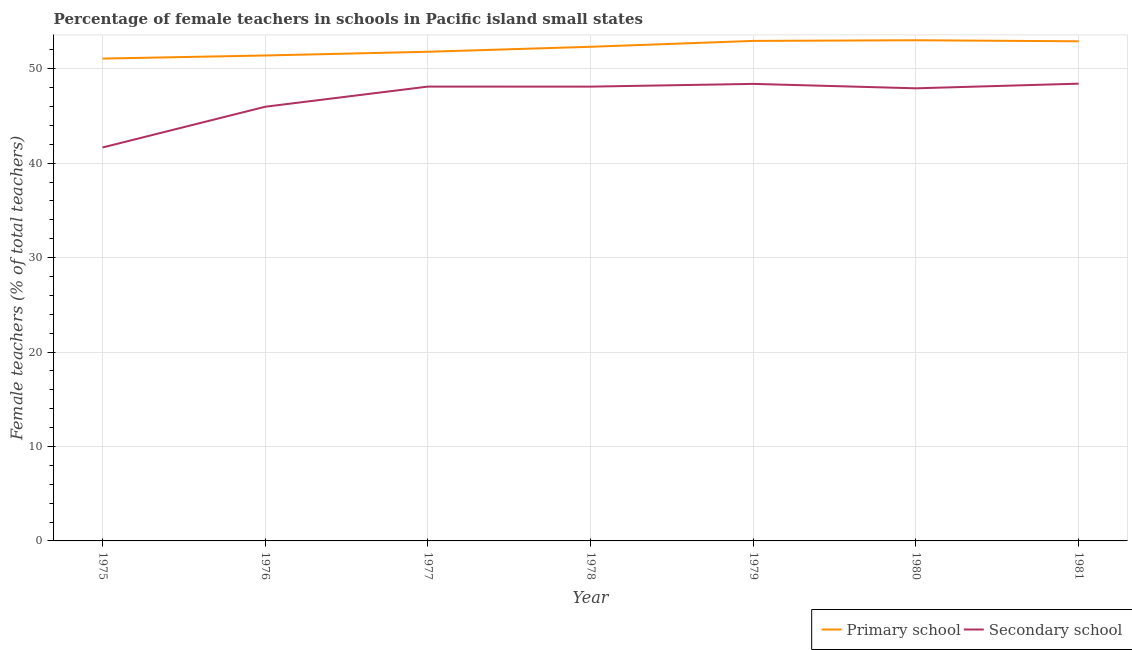How many different coloured lines are there?
Keep it short and to the point. 2. Does the line corresponding to percentage of female teachers in secondary schools intersect with the line corresponding to percentage of female teachers in primary schools?
Make the answer very short. No. What is the percentage of female teachers in secondary schools in 1979?
Your answer should be very brief. 48.4. Across all years, what is the maximum percentage of female teachers in primary schools?
Give a very brief answer. 53.02. Across all years, what is the minimum percentage of female teachers in secondary schools?
Your answer should be compact. 41.66. In which year was the percentage of female teachers in secondary schools minimum?
Your response must be concise. 1975. What is the total percentage of female teachers in secondary schools in the graph?
Offer a very short reply. 328.62. What is the difference between the percentage of female teachers in secondary schools in 1976 and that in 1980?
Provide a succinct answer. -1.95. What is the difference between the percentage of female teachers in secondary schools in 1976 and the percentage of female teachers in primary schools in 1979?
Keep it short and to the point. -6.97. What is the average percentage of female teachers in primary schools per year?
Offer a terse response. 52.21. In the year 1976, what is the difference between the percentage of female teachers in primary schools and percentage of female teachers in secondary schools?
Make the answer very short. 5.43. In how many years, is the percentage of female teachers in primary schools greater than 38 %?
Make the answer very short. 7. What is the ratio of the percentage of female teachers in secondary schools in 1975 to that in 1980?
Offer a very short reply. 0.87. Is the difference between the percentage of female teachers in primary schools in 1975 and 1977 greater than the difference between the percentage of female teachers in secondary schools in 1975 and 1977?
Offer a terse response. Yes. What is the difference between the highest and the second highest percentage of female teachers in secondary schools?
Your answer should be compact. 0.02. What is the difference between the highest and the lowest percentage of female teachers in secondary schools?
Make the answer very short. 6.76. Is the sum of the percentage of female teachers in secondary schools in 1979 and 1981 greater than the maximum percentage of female teachers in primary schools across all years?
Offer a terse response. Yes. Is the percentage of female teachers in primary schools strictly less than the percentage of female teachers in secondary schools over the years?
Give a very brief answer. No. What is the difference between two consecutive major ticks on the Y-axis?
Keep it short and to the point. 10. Where does the legend appear in the graph?
Keep it short and to the point. Bottom right. How many legend labels are there?
Your answer should be very brief. 2. How are the legend labels stacked?
Your response must be concise. Horizontal. What is the title of the graph?
Give a very brief answer. Percentage of female teachers in schools in Pacific island small states. What is the label or title of the Y-axis?
Your response must be concise. Female teachers (% of total teachers). What is the Female teachers (% of total teachers) in Primary school in 1975?
Keep it short and to the point. 51.08. What is the Female teachers (% of total teachers) of Secondary school in 1975?
Provide a succinct answer. 41.66. What is the Female teachers (% of total teachers) in Primary school in 1976?
Your answer should be compact. 51.41. What is the Female teachers (% of total teachers) of Secondary school in 1976?
Your answer should be very brief. 45.98. What is the Female teachers (% of total teachers) in Primary school in 1977?
Offer a terse response. 51.8. What is the Female teachers (% of total teachers) in Secondary school in 1977?
Keep it short and to the point. 48.11. What is the Female teachers (% of total teachers) of Primary school in 1978?
Your response must be concise. 52.33. What is the Female teachers (% of total teachers) of Secondary school in 1978?
Provide a short and direct response. 48.11. What is the Female teachers (% of total teachers) in Primary school in 1979?
Provide a short and direct response. 52.95. What is the Female teachers (% of total teachers) of Secondary school in 1979?
Offer a very short reply. 48.4. What is the Female teachers (% of total teachers) of Primary school in 1980?
Provide a succinct answer. 53.02. What is the Female teachers (% of total teachers) of Secondary school in 1980?
Give a very brief answer. 47.93. What is the Female teachers (% of total teachers) in Primary school in 1981?
Your answer should be very brief. 52.91. What is the Female teachers (% of total teachers) of Secondary school in 1981?
Provide a succinct answer. 48.42. Across all years, what is the maximum Female teachers (% of total teachers) in Primary school?
Keep it short and to the point. 53.02. Across all years, what is the maximum Female teachers (% of total teachers) of Secondary school?
Give a very brief answer. 48.42. Across all years, what is the minimum Female teachers (% of total teachers) in Primary school?
Provide a short and direct response. 51.08. Across all years, what is the minimum Female teachers (% of total teachers) in Secondary school?
Ensure brevity in your answer.  41.66. What is the total Female teachers (% of total teachers) of Primary school in the graph?
Keep it short and to the point. 365.5. What is the total Female teachers (% of total teachers) of Secondary school in the graph?
Your response must be concise. 328.62. What is the difference between the Female teachers (% of total teachers) of Primary school in 1975 and that in 1976?
Your answer should be compact. -0.33. What is the difference between the Female teachers (% of total teachers) of Secondary school in 1975 and that in 1976?
Give a very brief answer. -4.31. What is the difference between the Female teachers (% of total teachers) of Primary school in 1975 and that in 1977?
Keep it short and to the point. -0.72. What is the difference between the Female teachers (% of total teachers) of Secondary school in 1975 and that in 1977?
Provide a succinct answer. -6.45. What is the difference between the Female teachers (% of total teachers) in Primary school in 1975 and that in 1978?
Provide a short and direct response. -1.25. What is the difference between the Female teachers (% of total teachers) in Secondary school in 1975 and that in 1978?
Offer a terse response. -6.45. What is the difference between the Female teachers (% of total teachers) in Primary school in 1975 and that in 1979?
Your answer should be compact. -1.87. What is the difference between the Female teachers (% of total teachers) of Secondary school in 1975 and that in 1979?
Give a very brief answer. -6.73. What is the difference between the Female teachers (% of total teachers) in Primary school in 1975 and that in 1980?
Offer a terse response. -1.94. What is the difference between the Female teachers (% of total teachers) of Secondary school in 1975 and that in 1980?
Keep it short and to the point. -6.27. What is the difference between the Female teachers (% of total teachers) in Primary school in 1975 and that in 1981?
Offer a very short reply. -1.83. What is the difference between the Female teachers (% of total teachers) in Secondary school in 1975 and that in 1981?
Provide a succinct answer. -6.76. What is the difference between the Female teachers (% of total teachers) in Primary school in 1976 and that in 1977?
Provide a short and direct response. -0.39. What is the difference between the Female teachers (% of total teachers) of Secondary school in 1976 and that in 1977?
Provide a short and direct response. -2.13. What is the difference between the Female teachers (% of total teachers) in Primary school in 1976 and that in 1978?
Your answer should be compact. -0.92. What is the difference between the Female teachers (% of total teachers) of Secondary school in 1976 and that in 1978?
Offer a very short reply. -2.13. What is the difference between the Female teachers (% of total teachers) in Primary school in 1976 and that in 1979?
Offer a very short reply. -1.54. What is the difference between the Female teachers (% of total teachers) of Secondary school in 1976 and that in 1979?
Your answer should be compact. -2.42. What is the difference between the Female teachers (% of total teachers) of Primary school in 1976 and that in 1980?
Your response must be concise. -1.61. What is the difference between the Female teachers (% of total teachers) in Secondary school in 1976 and that in 1980?
Make the answer very short. -1.95. What is the difference between the Female teachers (% of total teachers) in Primary school in 1976 and that in 1981?
Offer a terse response. -1.5. What is the difference between the Female teachers (% of total teachers) of Secondary school in 1976 and that in 1981?
Your response must be concise. -2.44. What is the difference between the Female teachers (% of total teachers) of Primary school in 1977 and that in 1978?
Offer a terse response. -0.53. What is the difference between the Female teachers (% of total teachers) of Secondary school in 1977 and that in 1978?
Your answer should be compact. 0. What is the difference between the Female teachers (% of total teachers) in Primary school in 1977 and that in 1979?
Offer a very short reply. -1.15. What is the difference between the Female teachers (% of total teachers) of Secondary school in 1977 and that in 1979?
Offer a very short reply. -0.29. What is the difference between the Female teachers (% of total teachers) of Primary school in 1977 and that in 1980?
Your response must be concise. -1.22. What is the difference between the Female teachers (% of total teachers) in Secondary school in 1977 and that in 1980?
Ensure brevity in your answer.  0.18. What is the difference between the Female teachers (% of total teachers) of Primary school in 1977 and that in 1981?
Keep it short and to the point. -1.11. What is the difference between the Female teachers (% of total teachers) in Secondary school in 1977 and that in 1981?
Offer a very short reply. -0.31. What is the difference between the Female teachers (% of total teachers) of Primary school in 1978 and that in 1979?
Ensure brevity in your answer.  -0.62. What is the difference between the Female teachers (% of total teachers) in Secondary school in 1978 and that in 1979?
Provide a short and direct response. -0.29. What is the difference between the Female teachers (% of total teachers) in Primary school in 1978 and that in 1980?
Offer a very short reply. -0.69. What is the difference between the Female teachers (% of total teachers) in Secondary school in 1978 and that in 1980?
Your answer should be very brief. 0.18. What is the difference between the Female teachers (% of total teachers) in Primary school in 1978 and that in 1981?
Give a very brief answer. -0.58. What is the difference between the Female teachers (% of total teachers) of Secondary school in 1978 and that in 1981?
Keep it short and to the point. -0.31. What is the difference between the Female teachers (% of total teachers) in Primary school in 1979 and that in 1980?
Offer a very short reply. -0.07. What is the difference between the Female teachers (% of total teachers) of Secondary school in 1979 and that in 1980?
Your response must be concise. 0.47. What is the difference between the Female teachers (% of total teachers) in Primary school in 1979 and that in 1981?
Your response must be concise. 0.04. What is the difference between the Female teachers (% of total teachers) in Secondary school in 1979 and that in 1981?
Ensure brevity in your answer.  -0.02. What is the difference between the Female teachers (% of total teachers) of Primary school in 1980 and that in 1981?
Offer a very short reply. 0.11. What is the difference between the Female teachers (% of total teachers) of Secondary school in 1980 and that in 1981?
Provide a succinct answer. -0.49. What is the difference between the Female teachers (% of total teachers) of Primary school in 1975 and the Female teachers (% of total teachers) of Secondary school in 1976?
Provide a succinct answer. 5.1. What is the difference between the Female teachers (% of total teachers) in Primary school in 1975 and the Female teachers (% of total teachers) in Secondary school in 1977?
Your answer should be very brief. 2.97. What is the difference between the Female teachers (% of total teachers) of Primary school in 1975 and the Female teachers (% of total teachers) of Secondary school in 1978?
Make the answer very short. 2.97. What is the difference between the Female teachers (% of total teachers) in Primary school in 1975 and the Female teachers (% of total teachers) in Secondary school in 1979?
Provide a short and direct response. 2.68. What is the difference between the Female teachers (% of total teachers) in Primary school in 1975 and the Female teachers (% of total teachers) in Secondary school in 1980?
Give a very brief answer. 3.15. What is the difference between the Female teachers (% of total teachers) in Primary school in 1975 and the Female teachers (% of total teachers) in Secondary school in 1981?
Your answer should be compact. 2.66. What is the difference between the Female teachers (% of total teachers) in Primary school in 1976 and the Female teachers (% of total teachers) in Secondary school in 1977?
Provide a short and direct response. 3.29. What is the difference between the Female teachers (% of total teachers) of Primary school in 1976 and the Female teachers (% of total teachers) of Secondary school in 1978?
Offer a terse response. 3.3. What is the difference between the Female teachers (% of total teachers) in Primary school in 1976 and the Female teachers (% of total teachers) in Secondary school in 1979?
Ensure brevity in your answer.  3.01. What is the difference between the Female teachers (% of total teachers) of Primary school in 1976 and the Female teachers (% of total teachers) of Secondary school in 1980?
Your response must be concise. 3.48. What is the difference between the Female teachers (% of total teachers) in Primary school in 1976 and the Female teachers (% of total teachers) in Secondary school in 1981?
Make the answer very short. 2.98. What is the difference between the Female teachers (% of total teachers) in Primary school in 1977 and the Female teachers (% of total teachers) in Secondary school in 1978?
Ensure brevity in your answer.  3.69. What is the difference between the Female teachers (% of total teachers) of Primary school in 1977 and the Female teachers (% of total teachers) of Secondary school in 1979?
Your answer should be compact. 3.4. What is the difference between the Female teachers (% of total teachers) in Primary school in 1977 and the Female teachers (% of total teachers) in Secondary school in 1980?
Offer a very short reply. 3.87. What is the difference between the Female teachers (% of total teachers) in Primary school in 1977 and the Female teachers (% of total teachers) in Secondary school in 1981?
Give a very brief answer. 3.38. What is the difference between the Female teachers (% of total teachers) of Primary school in 1978 and the Female teachers (% of total teachers) of Secondary school in 1979?
Keep it short and to the point. 3.93. What is the difference between the Female teachers (% of total teachers) in Primary school in 1978 and the Female teachers (% of total teachers) in Secondary school in 1980?
Keep it short and to the point. 4.4. What is the difference between the Female teachers (% of total teachers) in Primary school in 1978 and the Female teachers (% of total teachers) in Secondary school in 1981?
Your response must be concise. 3.91. What is the difference between the Female teachers (% of total teachers) of Primary school in 1979 and the Female teachers (% of total teachers) of Secondary school in 1980?
Keep it short and to the point. 5.02. What is the difference between the Female teachers (% of total teachers) in Primary school in 1979 and the Female teachers (% of total teachers) in Secondary school in 1981?
Offer a very short reply. 4.53. What is the difference between the Female teachers (% of total teachers) in Primary school in 1980 and the Female teachers (% of total teachers) in Secondary school in 1981?
Provide a succinct answer. 4.6. What is the average Female teachers (% of total teachers) of Primary school per year?
Your answer should be compact. 52.21. What is the average Female teachers (% of total teachers) of Secondary school per year?
Your answer should be very brief. 46.95. In the year 1975, what is the difference between the Female teachers (% of total teachers) in Primary school and Female teachers (% of total teachers) in Secondary school?
Provide a succinct answer. 9.42. In the year 1976, what is the difference between the Female teachers (% of total teachers) of Primary school and Female teachers (% of total teachers) of Secondary school?
Your answer should be compact. 5.43. In the year 1977, what is the difference between the Female teachers (% of total teachers) in Primary school and Female teachers (% of total teachers) in Secondary school?
Provide a succinct answer. 3.69. In the year 1978, what is the difference between the Female teachers (% of total teachers) in Primary school and Female teachers (% of total teachers) in Secondary school?
Your answer should be compact. 4.22. In the year 1979, what is the difference between the Female teachers (% of total teachers) in Primary school and Female teachers (% of total teachers) in Secondary school?
Your answer should be compact. 4.55. In the year 1980, what is the difference between the Female teachers (% of total teachers) of Primary school and Female teachers (% of total teachers) of Secondary school?
Your response must be concise. 5.09. In the year 1981, what is the difference between the Female teachers (% of total teachers) of Primary school and Female teachers (% of total teachers) of Secondary school?
Your answer should be very brief. 4.49. What is the ratio of the Female teachers (% of total teachers) in Primary school in 1975 to that in 1976?
Provide a short and direct response. 0.99. What is the ratio of the Female teachers (% of total teachers) in Secondary school in 1975 to that in 1976?
Keep it short and to the point. 0.91. What is the ratio of the Female teachers (% of total teachers) in Primary school in 1975 to that in 1977?
Make the answer very short. 0.99. What is the ratio of the Female teachers (% of total teachers) in Secondary school in 1975 to that in 1977?
Give a very brief answer. 0.87. What is the ratio of the Female teachers (% of total teachers) of Primary school in 1975 to that in 1978?
Provide a succinct answer. 0.98. What is the ratio of the Female teachers (% of total teachers) in Secondary school in 1975 to that in 1978?
Give a very brief answer. 0.87. What is the ratio of the Female teachers (% of total teachers) of Primary school in 1975 to that in 1979?
Give a very brief answer. 0.96. What is the ratio of the Female teachers (% of total teachers) in Secondary school in 1975 to that in 1979?
Provide a succinct answer. 0.86. What is the ratio of the Female teachers (% of total teachers) in Primary school in 1975 to that in 1980?
Give a very brief answer. 0.96. What is the ratio of the Female teachers (% of total teachers) in Secondary school in 1975 to that in 1980?
Offer a terse response. 0.87. What is the ratio of the Female teachers (% of total teachers) in Primary school in 1975 to that in 1981?
Your answer should be very brief. 0.97. What is the ratio of the Female teachers (% of total teachers) in Secondary school in 1975 to that in 1981?
Provide a short and direct response. 0.86. What is the ratio of the Female teachers (% of total teachers) of Secondary school in 1976 to that in 1977?
Provide a succinct answer. 0.96. What is the ratio of the Female teachers (% of total teachers) of Primary school in 1976 to that in 1978?
Provide a short and direct response. 0.98. What is the ratio of the Female teachers (% of total teachers) in Secondary school in 1976 to that in 1978?
Provide a short and direct response. 0.96. What is the ratio of the Female teachers (% of total teachers) of Primary school in 1976 to that in 1979?
Ensure brevity in your answer.  0.97. What is the ratio of the Female teachers (% of total teachers) in Secondary school in 1976 to that in 1979?
Your response must be concise. 0.95. What is the ratio of the Female teachers (% of total teachers) of Primary school in 1976 to that in 1980?
Keep it short and to the point. 0.97. What is the ratio of the Female teachers (% of total teachers) in Secondary school in 1976 to that in 1980?
Offer a very short reply. 0.96. What is the ratio of the Female teachers (% of total teachers) of Primary school in 1976 to that in 1981?
Ensure brevity in your answer.  0.97. What is the ratio of the Female teachers (% of total teachers) of Secondary school in 1976 to that in 1981?
Your answer should be compact. 0.95. What is the ratio of the Female teachers (% of total teachers) in Primary school in 1977 to that in 1978?
Offer a very short reply. 0.99. What is the ratio of the Female teachers (% of total teachers) in Secondary school in 1977 to that in 1978?
Offer a terse response. 1. What is the ratio of the Female teachers (% of total teachers) of Primary school in 1977 to that in 1979?
Your response must be concise. 0.98. What is the ratio of the Female teachers (% of total teachers) of Secondary school in 1977 to that in 1979?
Offer a very short reply. 0.99. What is the ratio of the Female teachers (% of total teachers) of Secondary school in 1977 to that in 1980?
Provide a succinct answer. 1. What is the ratio of the Female teachers (% of total teachers) in Primary school in 1977 to that in 1981?
Your answer should be compact. 0.98. What is the ratio of the Female teachers (% of total teachers) in Secondary school in 1977 to that in 1981?
Make the answer very short. 0.99. What is the ratio of the Female teachers (% of total teachers) in Primary school in 1978 to that in 1979?
Your answer should be very brief. 0.99. What is the ratio of the Female teachers (% of total teachers) of Secondary school in 1978 to that in 1979?
Your response must be concise. 0.99. What is the ratio of the Female teachers (% of total teachers) in Primary school in 1978 to that in 1980?
Ensure brevity in your answer.  0.99. What is the ratio of the Female teachers (% of total teachers) in Primary school in 1979 to that in 1980?
Your response must be concise. 1. What is the ratio of the Female teachers (% of total teachers) of Secondary school in 1979 to that in 1980?
Keep it short and to the point. 1.01. What is the ratio of the Female teachers (% of total teachers) of Secondary school in 1979 to that in 1981?
Provide a short and direct response. 1. What is the ratio of the Female teachers (% of total teachers) of Secondary school in 1980 to that in 1981?
Ensure brevity in your answer.  0.99. What is the difference between the highest and the second highest Female teachers (% of total teachers) of Primary school?
Ensure brevity in your answer.  0.07. What is the difference between the highest and the second highest Female teachers (% of total teachers) in Secondary school?
Offer a terse response. 0.02. What is the difference between the highest and the lowest Female teachers (% of total teachers) in Primary school?
Your response must be concise. 1.94. What is the difference between the highest and the lowest Female teachers (% of total teachers) of Secondary school?
Make the answer very short. 6.76. 